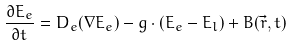<formula> <loc_0><loc_0><loc_500><loc_500>\frac { \partial E _ { e } } { \partial t } = D _ { e } ( \nabla E _ { e } ) - g \cdot ( E _ { e } - E _ { l } ) + B ( \vec { r } , t )</formula> 